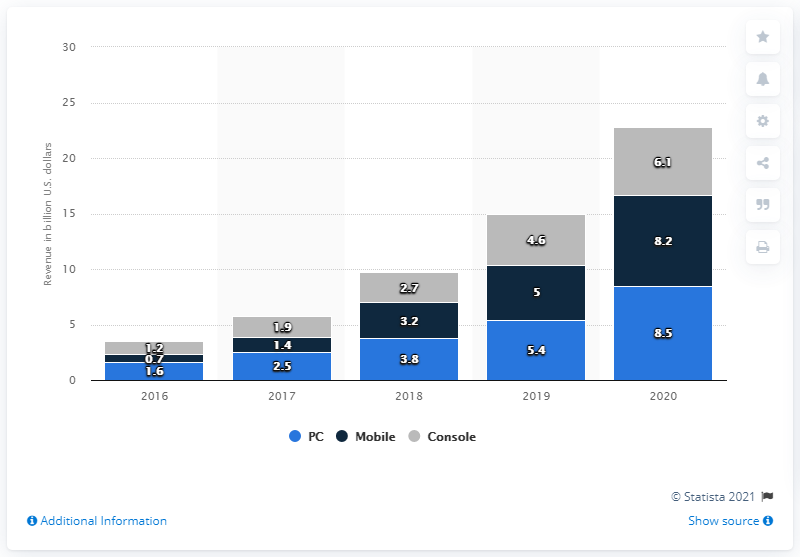Mention a couple of crucial points in this snapshot. The difference between the averages of mobile and PC users is 0.66. The use of gray in the graph indicates the console output in the given code. According to the given information, it can be declared that PC VR software and hardware are expected to account for approximately 1.6% of the global VR gaming market. 